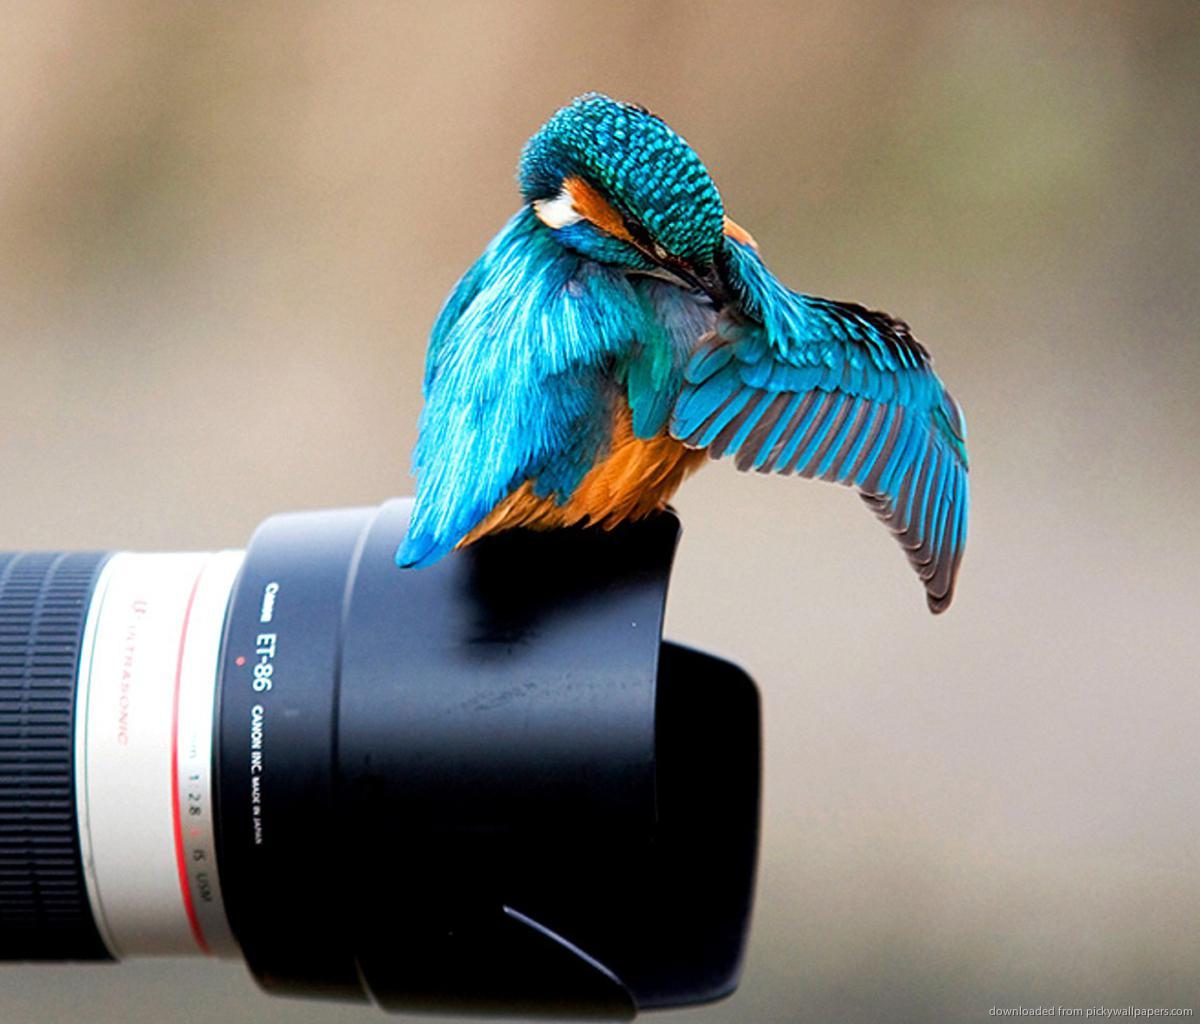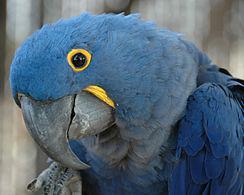The first image is the image on the left, the second image is the image on the right. Assess this claim about the two images: "In at least one image, a single bird is pictured that lacks a yellow ring around the eye and has a small straight beak.". Correct or not? Answer yes or no. Yes. The first image is the image on the left, the second image is the image on the right. Examine the images to the left and right. Is the description "All images show a blue-feathered bird perched on something resembling wood." accurate? Answer yes or no. No. 